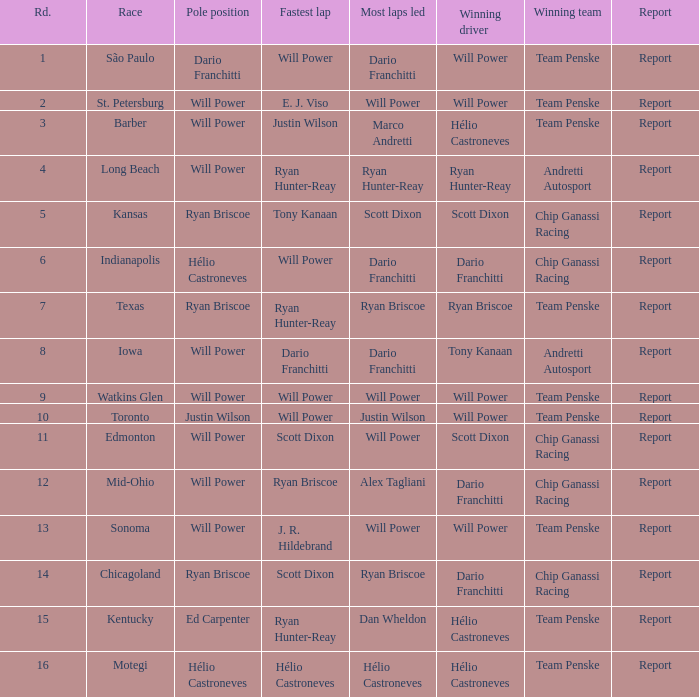What is the record for contests where will power held both pole position and swiftest lap? Report. 